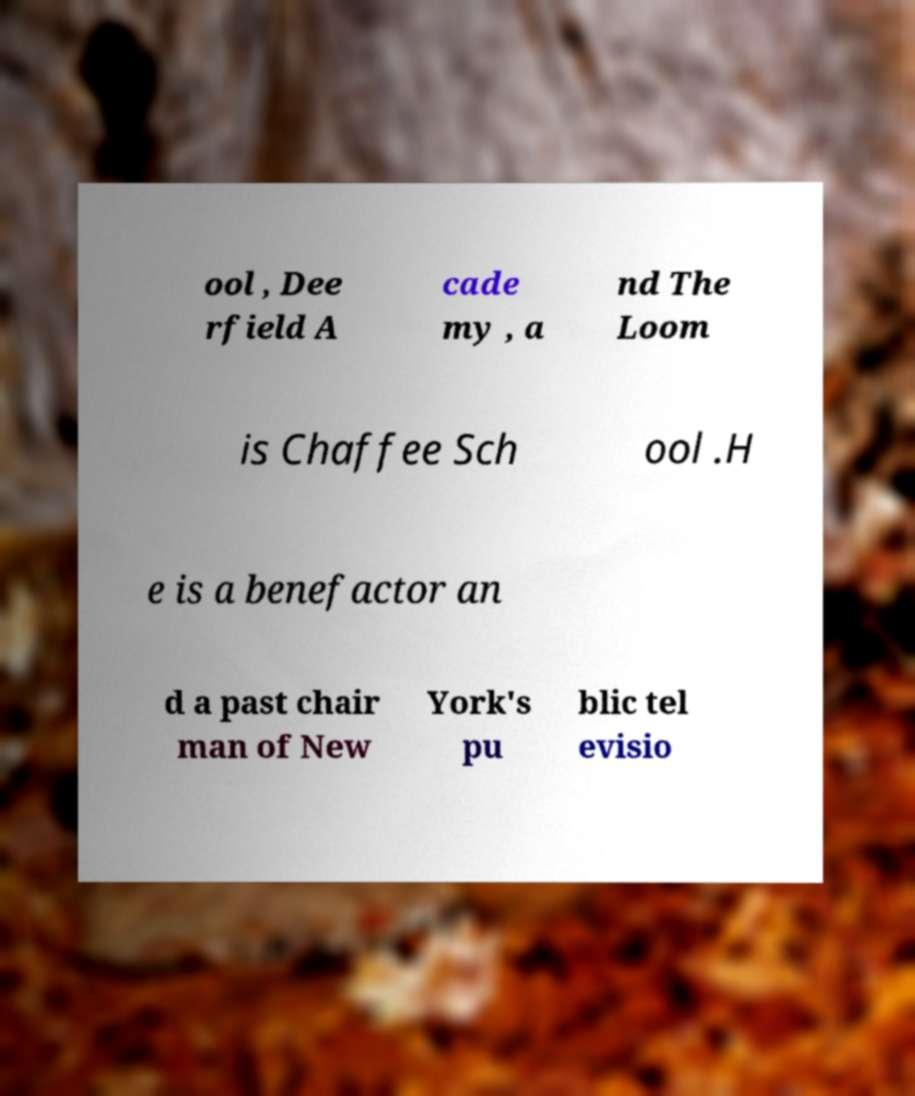I need the written content from this picture converted into text. Can you do that? ool , Dee rfield A cade my , a nd The Loom is Chaffee Sch ool .H e is a benefactor an d a past chair man of New York's pu blic tel evisio 